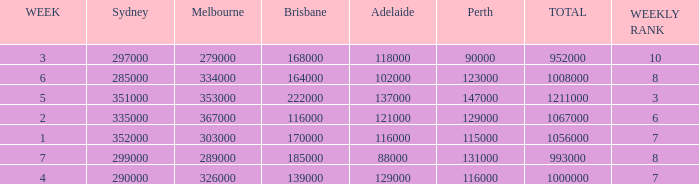How many episodes aired in Sydney in Week 3? 1.0. 